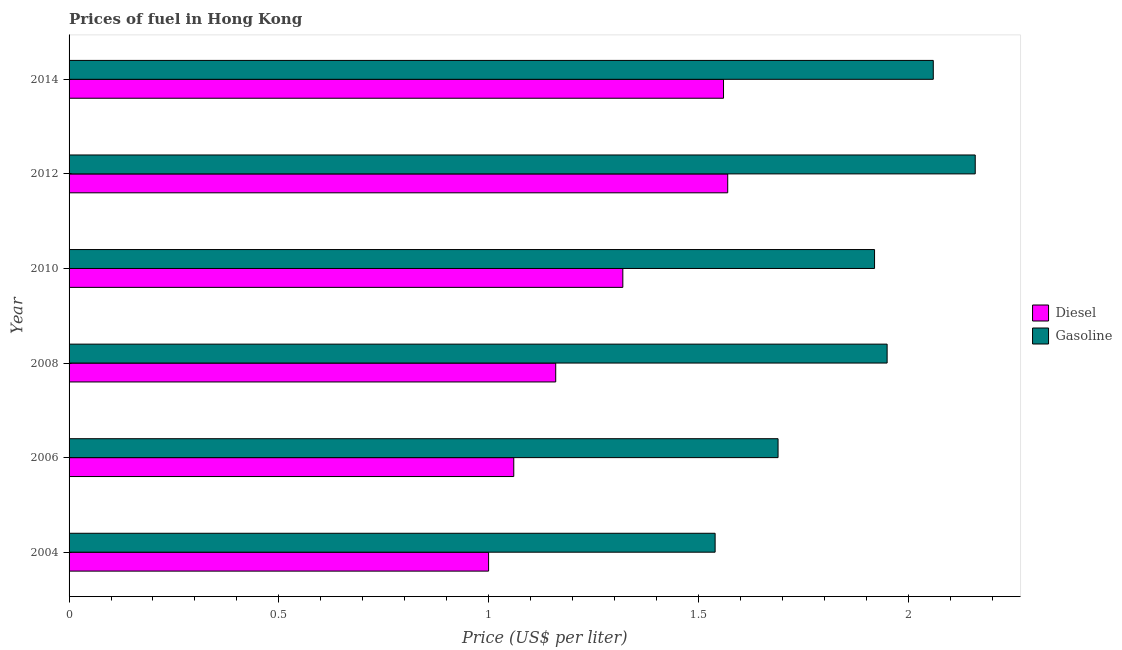How many groups of bars are there?
Offer a very short reply. 6. Are the number of bars on each tick of the Y-axis equal?
Offer a very short reply. Yes. How many bars are there on the 6th tick from the top?
Provide a succinct answer. 2. What is the label of the 5th group of bars from the top?
Provide a succinct answer. 2006. What is the diesel price in 2010?
Offer a very short reply. 1.32. Across all years, what is the maximum diesel price?
Your answer should be compact. 1.57. Across all years, what is the minimum diesel price?
Offer a very short reply. 1. In which year was the diesel price minimum?
Make the answer very short. 2004. What is the total diesel price in the graph?
Offer a very short reply. 7.67. What is the difference between the gasoline price in 2006 and that in 2014?
Provide a short and direct response. -0.37. What is the difference between the diesel price in 2006 and the gasoline price in 2012?
Offer a terse response. -1.1. What is the average gasoline price per year?
Offer a terse response. 1.89. What is the ratio of the gasoline price in 2012 to that in 2014?
Offer a terse response. 1.05. Is the difference between the diesel price in 2012 and 2014 greater than the difference between the gasoline price in 2012 and 2014?
Offer a very short reply. No. What is the difference between the highest and the second highest diesel price?
Give a very brief answer. 0.01. What is the difference between the highest and the lowest gasoline price?
Ensure brevity in your answer.  0.62. Is the sum of the diesel price in 2004 and 2014 greater than the maximum gasoline price across all years?
Your answer should be compact. Yes. What does the 1st bar from the top in 2012 represents?
Provide a short and direct response. Gasoline. What does the 1st bar from the bottom in 2014 represents?
Give a very brief answer. Diesel. How many bars are there?
Your response must be concise. 12. Are all the bars in the graph horizontal?
Provide a succinct answer. Yes. Are the values on the major ticks of X-axis written in scientific E-notation?
Make the answer very short. No. Does the graph contain any zero values?
Provide a short and direct response. No. Where does the legend appear in the graph?
Ensure brevity in your answer.  Center right. How many legend labels are there?
Make the answer very short. 2. How are the legend labels stacked?
Your answer should be compact. Vertical. What is the title of the graph?
Offer a very short reply. Prices of fuel in Hong Kong. Does "Short-term debt" appear as one of the legend labels in the graph?
Offer a very short reply. No. What is the label or title of the X-axis?
Make the answer very short. Price (US$ per liter). What is the Price (US$ per liter) in Gasoline in 2004?
Give a very brief answer. 1.54. What is the Price (US$ per liter) in Diesel in 2006?
Your answer should be compact. 1.06. What is the Price (US$ per liter) in Gasoline in 2006?
Offer a very short reply. 1.69. What is the Price (US$ per liter) of Diesel in 2008?
Your answer should be very brief. 1.16. What is the Price (US$ per liter) of Gasoline in 2008?
Keep it short and to the point. 1.95. What is the Price (US$ per liter) of Diesel in 2010?
Make the answer very short. 1.32. What is the Price (US$ per liter) of Gasoline in 2010?
Make the answer very short. 1.92. What is the Price (US$ per liter) of Diesel in 2012?
Your answer should be compact. 1.57. What is the Price (US$ per liter) in Gasoline in 2012?
Ensure brevity in your answer.  2.16. What is the Price (US$ per liter) of Diesel in 2014?
Keep it short and to the point. 1.56. What is the Price (US$ per liter) of Gasoline in 2014?
Offer a terse response. 2.06. Across all years, what is the maximum Price (US$ per liter) in Diesel?
Keep it short and to the point. 1.57. Across all years, what is the maximum Price (US$ per liter) in Gasoline?
Offer a very short reply. 2.16. Across all years, what is the minimum Price (US$ per liter) of Gasoline?
Make the answer very short. 1.54. What is the total Price (US$ per liter) of Diesel in the graph?
Ensure brevity in your answer.  7.67. What is the total Price (US$ per liter) in Gasoline in the graph?
Offer a very short reply. 11.32. What is the difference between the Price (US$ per liter) in Diesel in 2004 and that in 2006?
Give a very brief answer. -0.06. What is the difference between the Price (US$ per liter) in Diesel in 2004 and that in 2008?
Keep it short and to the point. -0.16. What is the difference between the Price (US$ per liter) of Gasoline in 2004 and that in 2008?
Offer a terse response. -0.41. What is the difference between the Price (US$ per liter) in Diesel in 2004 and that in 2010?
Provide a short and direct response. -0.32. What is the difference between the Price (US$ per liter) of Gasoline in 2004 and that in 2010?
Your answer should be very brief. -0.38. What is the difference between the Price (US$ per liter) in Diesel in 2004 and that in 2012?
Give a very brief answer. -0.57. What is the difference between the Price (US$ per liter) of Gasoline in 2004 and that in 2012?
Keep it short and to the point. -0.62. What is the difference between the Price (US$ per liter) in Diesel in 2004 and that in 2014?
Offer a terse response. -0.56. What is the difference between the Price (US$ per liter) of Gasoline in 2004 and that in 2014?
Make the answer very short. -0.52. What is the difference between the Price (US$ per liter) in Gasoline in 2006 and that in 2008?
Provide a succinct answer. -0.26. What is the difference between the Price (US$ per liter) in Diesel in 2006 and that in 2010?
Make the answer very short. -0.26. What is the difference between the Price (US$ per liter) of Gasoline in 2006 and that in 2010?
Your response must be concise. -0.23. What is the difference between the Price (US$ per liter) in Diesel in 2006 and that in 2012?
Make the answer very short. -0.51. What is the difference between the Price (US$ per liter) in Gasoline in 2006 and that in 2012?
Make the answer very short. -0.47. What is the difference between the Price (US$ per liter) of Diesel in 2006 and that in 2014?
Keep it short and to the point. -0.5. What is the difference between the Price (US$ per liter) in Gasoline in 2006 and that in 2014?
Offer a very short reply. -0.37. What is the difference between the Price (US$ per liter) in Diesel in 2008 and that in 2010?
Keep it short and to the point. -0.16. What is the difference between the Price (US$ per liter) of Gasoline in 2008 and that in 2010?
Offer a terse response. 0.03. What is the difference between the Price (US$ per liter) of Diesel in 2008 and that in 2012?
Keep it short and to the point. -0.41. What is the difference between the Price (US$ per liter) in Gasoline in 2008 and that in 2012?
Offer a terse response. -0.21. What is the difference between the Price (US$ per liter) in Diesel in 2008 and that in 2014?
Offer a terse response. -0.4. What is the difference between the Price (US$ per liter) of Gasoline in 2008 and that in 2014?
Give a very brief answer. -0.11. What is the difference between the Price (US$ per liter) in Gasoline in 2010 and that in 2012?
Ensure brevity in your answer.  -0.24. What is the difference between the Price (US$ per liter) in Diesel in 2010 and that in 2014?
Keep it short and to the point. -0.24. What is the difference between the Price (US$ per liter) of Gasoline in 2010 and that in 2014?
Ensure brevity in your answer.  -0.14. What is the difference between the Price (US$ per liter) of Diesel in 2004 and the Price (US$ per liter) of Gasoline in 2006?
Provide a succinct answer. -0.69. What is the difference between the Price (US$ per liter) of Diesel in 2004 and the Price (US$ per liter) of Gasoline in 2008?
Ensure brevity in your answer.  -0.95. What is the difference between the Price (US$ per liter) of Diesel in 2004 and the Price (US$ per liter) of Gasoline in 2010?
Your answer should be very brief. -0.92. What is the difference between the Price (US$ per liter) in Diesel in 2004 and the Price (US$ per liter) in Gasoline in 2012?
Your answer should be very brief. -1.16. What is the difference between the Price (US$ per liter) in Diesel in 2004 and the Price (US$ per liter) in Gasoline in 2014?
Make the answer very short. -1.06. What is the difference between the Price (US$ per liter) in Diesel in 2006 and the Price (US$ per liter) in Gasoline in 2008?
Provide a succinct answer. -0.89. What is the difference between the Price (US$ per liter) in Diesel in 2006 and the Price (US$ per liter) in Gasoline in 2010?
Your answer should be compact. -0.86. What is the difference between the Price (US$ per liter) of Diesel in 2008 and the Price (US$ per liter) of Gasoline in 2010?
Keep it short and to the point. -0.76. What is the difference between the Price (US$ per liter) of Diesel in 2008 and the Price (US$ per liter) of Gasoline in 2012?
Give a very brief answer. -1. What is the difference between the Price (US$ per liter) in Diesel in 2010 and the Price (US$ per liter) in Gasoline in 2012?
Your response must be concise. -0.84. What is the difference between the Price (US$ per liter) in Diesel in 2010 and the Price (US$ per liter) in Gasoline in 2014?
Your answer should be compact. -0.74. What is the difference between the Price (US$ per liter) of Diesel in 2012 and the Price (US$ per liter) of Gasoline in 2014?
Ensure brevity in your answer.  -0.49. What is the average Price (US$ per liter) of Diesel per year?
Ensure brevity in your answer.  1.28. What is the average Price (US$ per liter) of Gasoline per year?
Your answer should be very brief. 1.89. In the year 2004, what is the difference between the Price (US$ per liter) in Diesel and Price (US$ per liter) in Gasoline?
Your response must be concise. -0.54. In the year 2006, what is the difference between the Price (US$ per liter) in Diesel and Price (US$ per liter) in Gasoline?
Provide a short and direct response. -0.63. In the year 2008, what is the difference between the Price (US$ per liter) in Diesel and Price (US$ per liter) in Gasoline?
Your answer should be very brief. -0.79. In the year 2012, what is the difference between the Price (US$ per liter) of Diesel and Price (US$ per liter) of Gasoline?
Keep it short and to the point. -0.59. In the year 2014, what is the difference between the Price (US$ per liter) in Diesel and Price (US$ per liter) in Gasoline?
Ensure brevity in your answer.  -0.5. What is the ratio of the Price (US$ per liter) of Diesel in 2004 to that in 2006?
Ensure brevity in your answer.  0.94. What is the ratio of the Price (US$ per liter) of Gasoline in 2004 to that in 2006?
Offer a terse response. 0.91. What is the ratio of the Price (US$ per liter) in Diesel in 2004 to that in 2008?
Provide a short and direct response. 0.86. What is the ratio of the Price (US$ per liter) of Gasoline in 2004 to that in 2008?
Keep it short and to the point. 0.79. What is the ratio of the Price (US$ per liter) in Diesel in 2004 to that in 2010?
Your answer should be very brief. 0.76. What is the ratio of the Price (US$ per liter) in Gasoline in 2004 to that in 2010?
Keep it short and to the point. 0.8. What is the ratio of the Price (US$ per liter) of Diesel in 2004 to that in 2012?
Offer a very short reply. 0.64. What is the ratio of the Price (US$ per liter) of Gasoline in 2004 to that in 2012?
Offer a very short reply. 0.71. What is the ratio of the Price (US$ per liter) of Diesel in 2004 to that in 2014?
Your response must be concise. 0.64. What is the ratio of the Price (US$ per liter) of Gasoline in 2004 to that in 2014?
Your response must be concise. 0.75. What is the ratio of the Price (US$ per liter) in Diesel in 2006 to that in 2008?
Make the answer very short. 0.91. What is the ratio of the Price (US$ per liter) in Gasoline in 2006 to that in 2008?
Provide a succinct answer. 0.87. What is the ratio of the Price (US$ per liter) of Diesel in 2006 to that in 2010?
Offer a very short reply. 0.8. What is the ratio of the Price (US$ per liter) in Gasoline in 2006 to that in 2010?
Your response must be concise. 0.88. What is the ratio of the Price (US$ per liter) of Diesel in 2006 to that in 2012?
Provide a succinct answer. 0.68. What is the ratio of the Price (US$ per liter) in Gasoline in 2006 to that in 2012?
Give a very brief answer. 0.78. What is the ratio of the Price (US$ per liter) in Diesel in 2006 to that in 2014?
Your answer should be compact. 0.68. What is the ratio of the Price (US$ per liter) of Gasoline in 2006 to that in 2014?
Your response must be concise. 0.82. What is the ratio of the Price (US$ per liter) of Diesel in 2008 to that in 2010?
Keep it short and to the point. 0.88. What is the ratio of the Price (US$ per liter) of Gasoline in 2008 to that in 2010?
Keep it short and to the point. 1.02. What is the ratio of the Price (US$ per liter) in Diesel in 2008 to that in 2012?
Your answer should be very brief. 0.74. What is the ratio of the Price (US$ per liter) in Gasoline in 2008 to that in 2012?
Keep it short and to the point. 0.9. What is the ratio of the Price (US$ per liter) of Diesel in 2008 to that in 2014?
Keep it short and to the point. 0.74. What is the ratio of the Price (US$ per liter) in Gasoline in 2008 to that in 2014?
Ensure brevity in your answer.  0.95. What is the ratio of the Price (US$ per liter) of Diesel in 2010 to that in 2012?
Keep it short and to the point. 0.84. What is the ratio of the Price (US$ per liter) of Gasoline in 2010 to that in 2012?
Your answer should be compact. 0.89. What is the ratio of the Price (US$ per liter) in Diesel in 2010 to that in 2014?
Provide a succinct answer. 0.85. What is the ratio of the Price (US$ per liter) of Gasoline in 2010 to that in 2014?
Give a very brief answer. 0.93. What is the ratio of the Price (US$ per liter) in Diesel in 2012 to that in 2014?
Offer a very short reply. 1.01. What is the ratio of the Price (US$ per liter) of Gasoline in 2012 to that in 2014?
Your answer should be compact. 1.05. What is the difference between the highest and the second highest Price (US$ per liter) of Diesel?
Offer a terse response. 0.01. What is the difference between the highest and the lowest Price (US$ per liter) in Diesel?
Give a very brief answer. 0.57. What is the difference between the highest and the lowest Price (US$ per liter) of Gasoline?
Give a very brief answer. 0.62. 